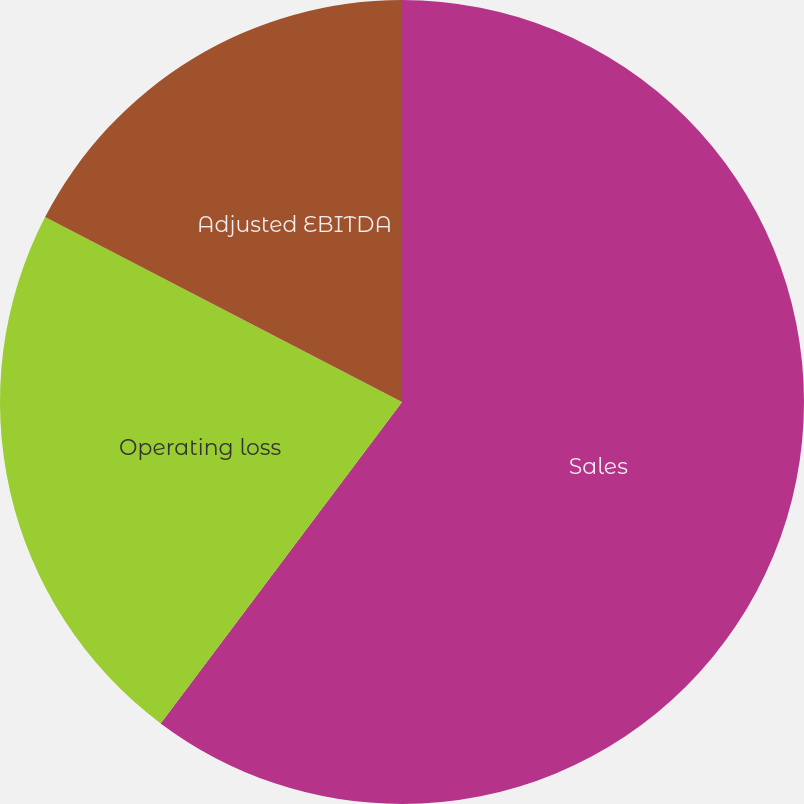<chart> <loc_0><loc_0><loc_500><loc_500><pie_chart><fcel>Sales<fcel>Operating loss<fcel>Adjusted EBITDA<nl><fcel>60.25%<fcel>22.36%<fcel>17.39%<nl></chart> 